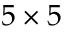<formula> <loc_0><loc_0><loc_500><loc_500>5 \times 5</formula> 